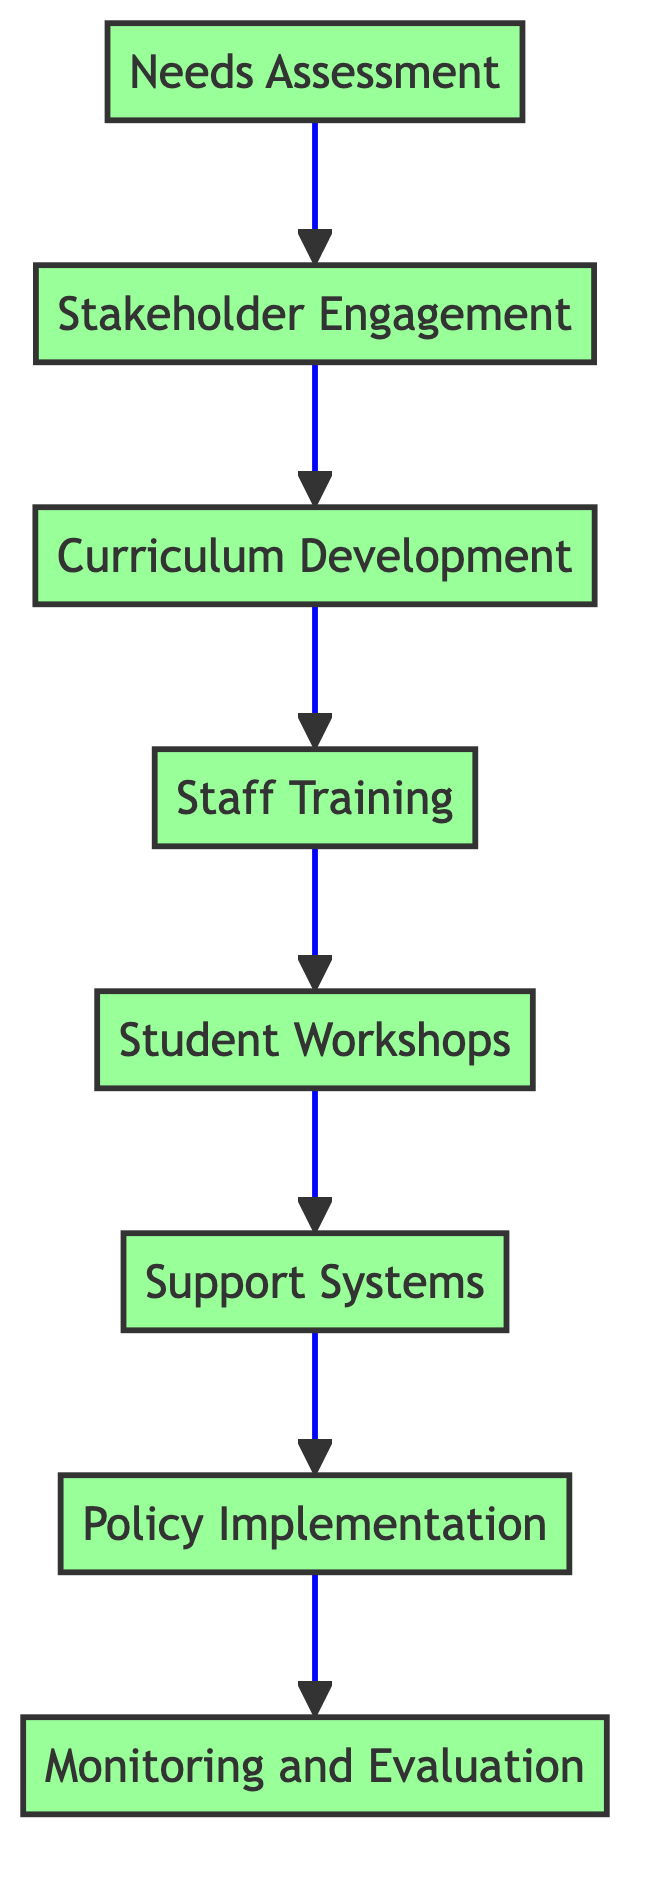What is the first step in the training program? The diagram indicates that the first step is "Needs Assessment." This node has no dependencies above it, thus it is the starting point of the flowchart.
Answer: Needs Assessment How many total steps are there in this training program? By counting the nodes in the flowchart, there are eight steps: Needs Assessment, Stakeholder Engagement, Curriculum Development, Staff Training, Student Workshops, Support Systems, Policy Implementation, and Monitoring and Evaluation.
Answer: Eight Which step comes immediately after "Student Workshops"? The diagram shows that the node directly following "Student Workshops" is "Support Systems." This is evident from the single arrow connecting the two steps.
Answer: Support Systems What is a prerequisite for "Curriculum Development"? The diagram indicates that "Stakeholder Engagement" must be completed before "Curriculum Development" can take place, as shown by the arrow leading from the former to the latter.
Answer: Stakeholder Engagement How does "Monitoring and Evaluation" relate to "Policy Implementation"? The flowchart shows that "Monitoring and Evaluation" follows "Policy Implementation," indicating that the implementation of policy must occur before the evaluation can commence.
Answer: Follows What type of node is "Staff Training"? "Staff Training" is a process node in the context of the flowchart, as it involves an action (organizing workshops and seminars) that contributes to the training program's overall goal.
Answer: Process node What is the ultimate goal of the flowchart? The ultimate goal of the flowchart is to ensure a comprehensive training program that fosters LGBTQ sensitivity throughout schools, culminating in the "Monitoring and Evaluation" step to assess the effectiveness of the program.
Answer: Comprehensive training program Which node is the last step of the training program? According to the flowchart, the last step is "Monitoring and Evaluation," as it is the final node in the series of connected steps, indicating a cyclical assessment process after implementation.
Answer: Monitoring and Evaluation 